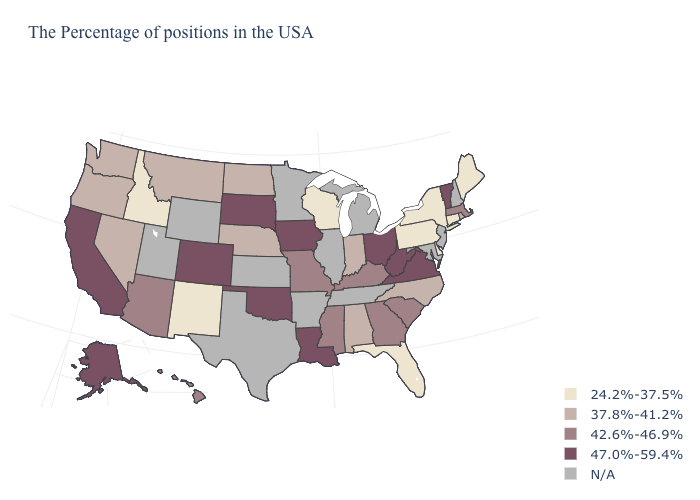Among the states that border Michigan , does Wisconsin have the highest value?
Short answer required. No. How many symbols are there in the legend?
Write a very short answer. 5. Name the states that have a value in the range 47.0%-59.4%?
Answer briefly. Vermont, Virginia, West Virginia, Ohio, Louisiana, Iowa, Oklahoma, South Dakota, Colorado, California, Alaska. Among the states that border Rhode Island , does Connecticut have the highest value?
Quick response, please. No. Does Idaho have the highest value in the USA?
Answer briefly. No. What is the value of New Mexico?
Concise answer only. 24.2%-37.5%. What is the value of Hawaii?
Be succinct. 42.6%-46.9%. What is the value of Washington?
Answer briefly. 37.8%-41.2%. Does Louisiana have the lowest value in the USA?
Quick response, please. No. What is the highest value in the Northeast ?
Be succinct. 47.0%-59.4%. Which states hav the highest value in the Northeast?
Answer briefly. Vermont. What is the value of South Carolina?
Be succinct. 42.6%-46.9%. Which states have the highest value in the USA?
Give a very brief answer. Vermont, Virginia, West Virginia, Ohio, Louisiana, Iowa, Oklahoma, South Dakota, Colorado, California, Alaska. What is the value of Nevada?
Give a very brief answer. 37.8%-41.2%. 